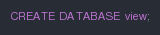Convert code to text. <code><loc_0><loc_0><loc_500><loc_500><_SQL_>CREATE DATABASE view;</code> 